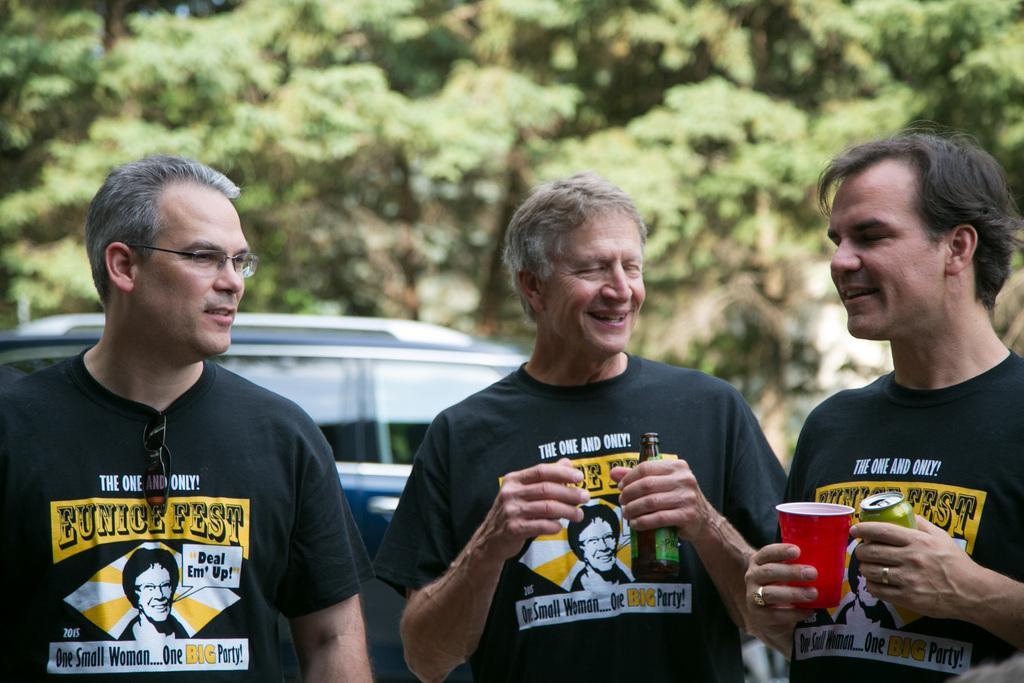Describe this image in one or two sentences. In this picture, we see three men standing on road. Man on the right corner of the picture wearing black t-shirt is holding coke bottle in one of his hand. On other hand, he is holding a red glass. Beside him, we see an old man wearing white black t-shirt is holding glass bottle in his hands and he is laughing. Beside him, the man who is wearing spectacles is standing and smiling. Behind them, we see vehicles and behind the vehicles we see trees. 